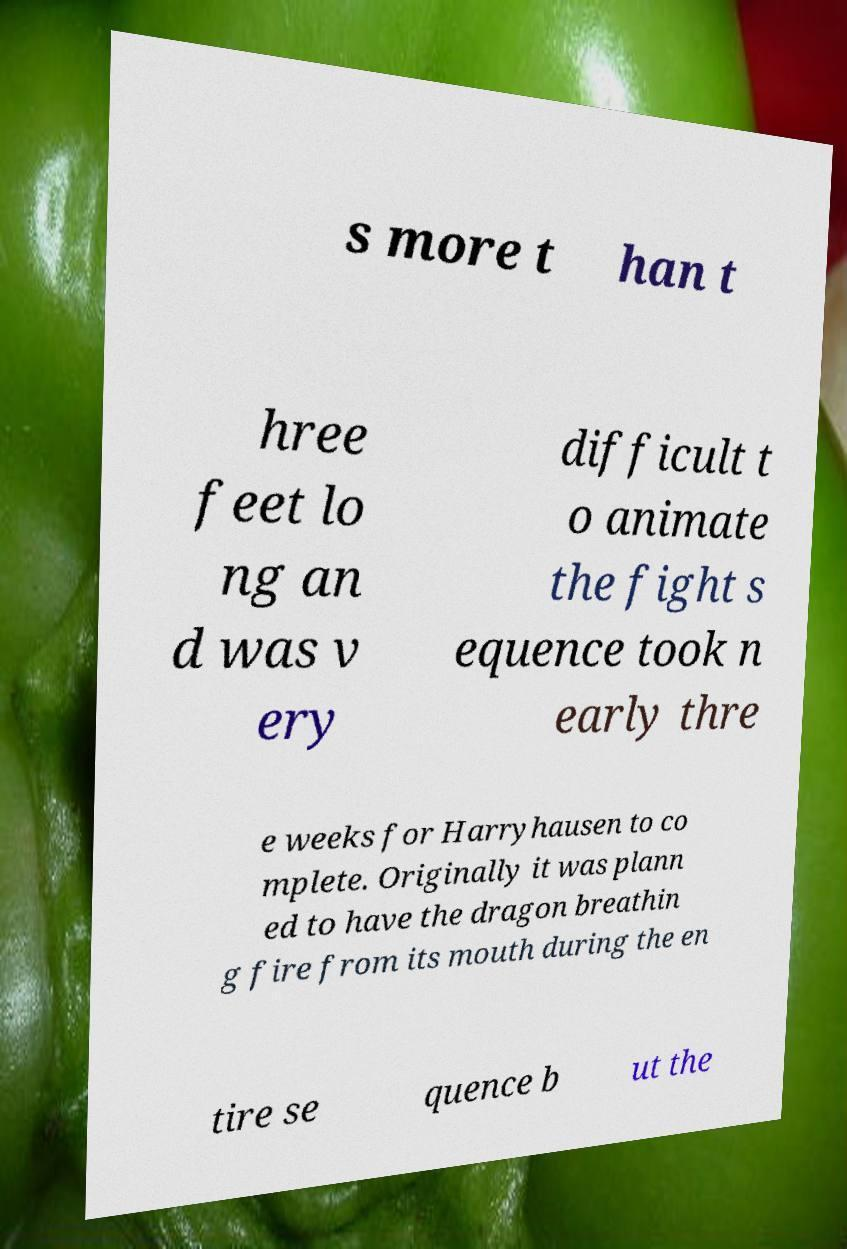Please read and relay the text visible in this image. What does it say? s more t han t hree feet lo ng an d was v ery difficult t o animate the fight s equence took n early thre e weeks for Harryhausen to co mplete. Originally it was plann ed to have the dragon breathin g fire from its mouth during the en tire se quence b ut the 